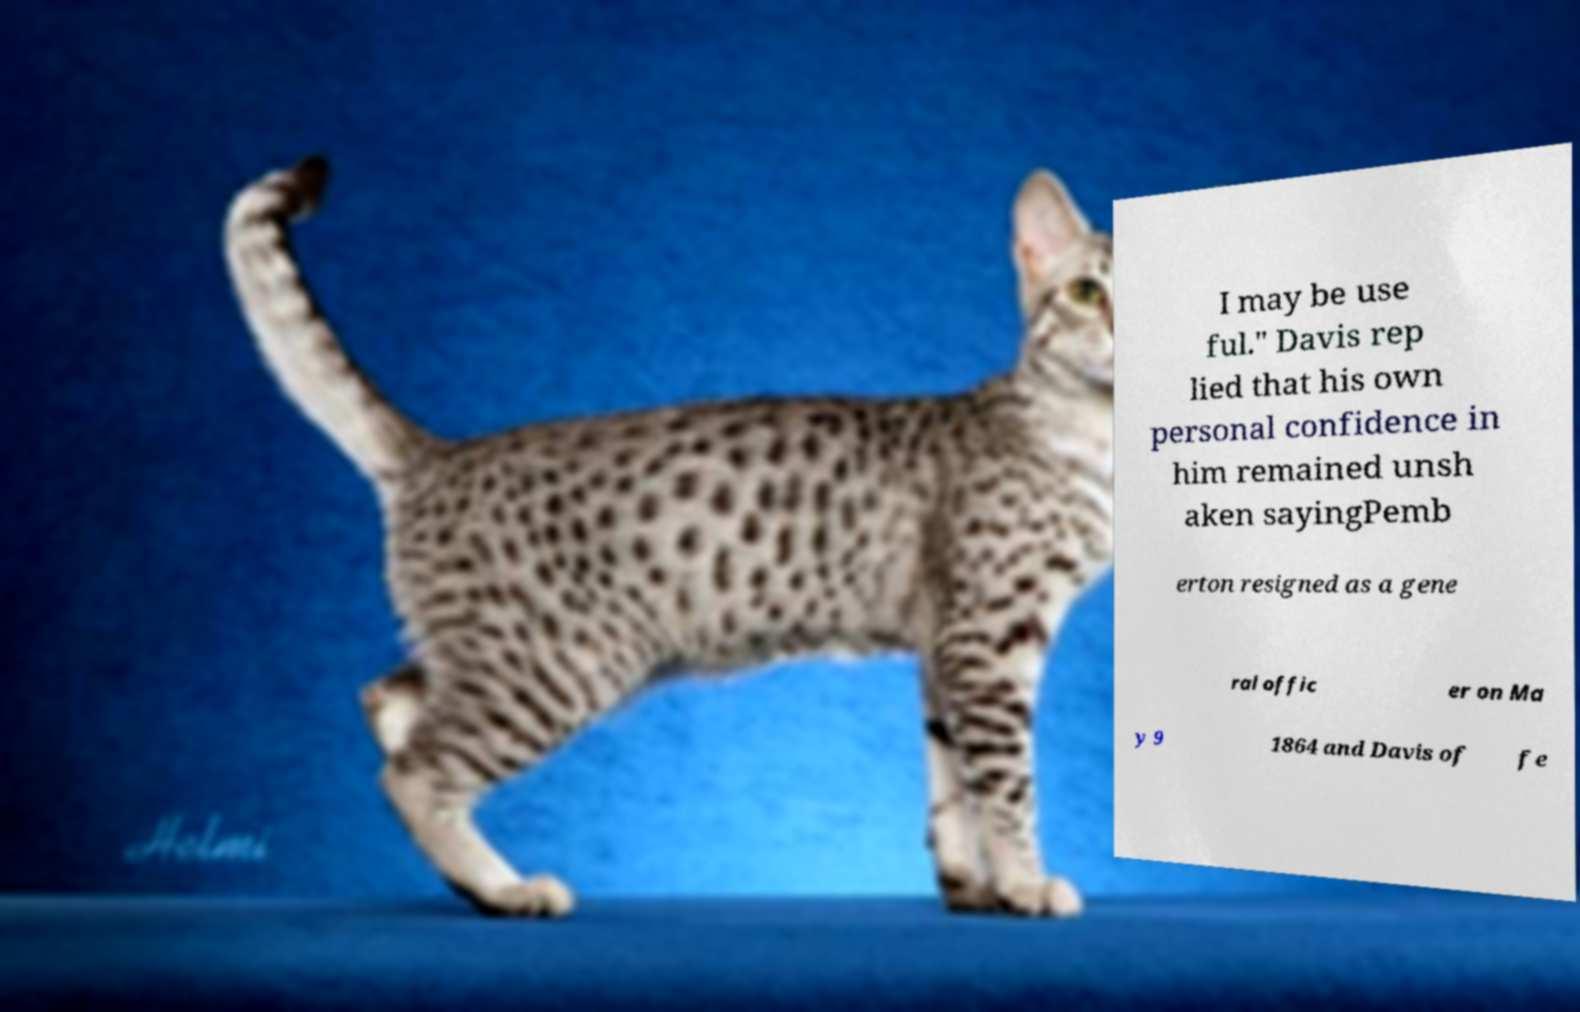Could you extract and type out the text from this image? I may be use ful." Davis rep lied that his own personal confidence in him remained unsh aken sayingPemb erton resigned as a gene ral offic er on Ma y 9 1864 and Davis of fe 